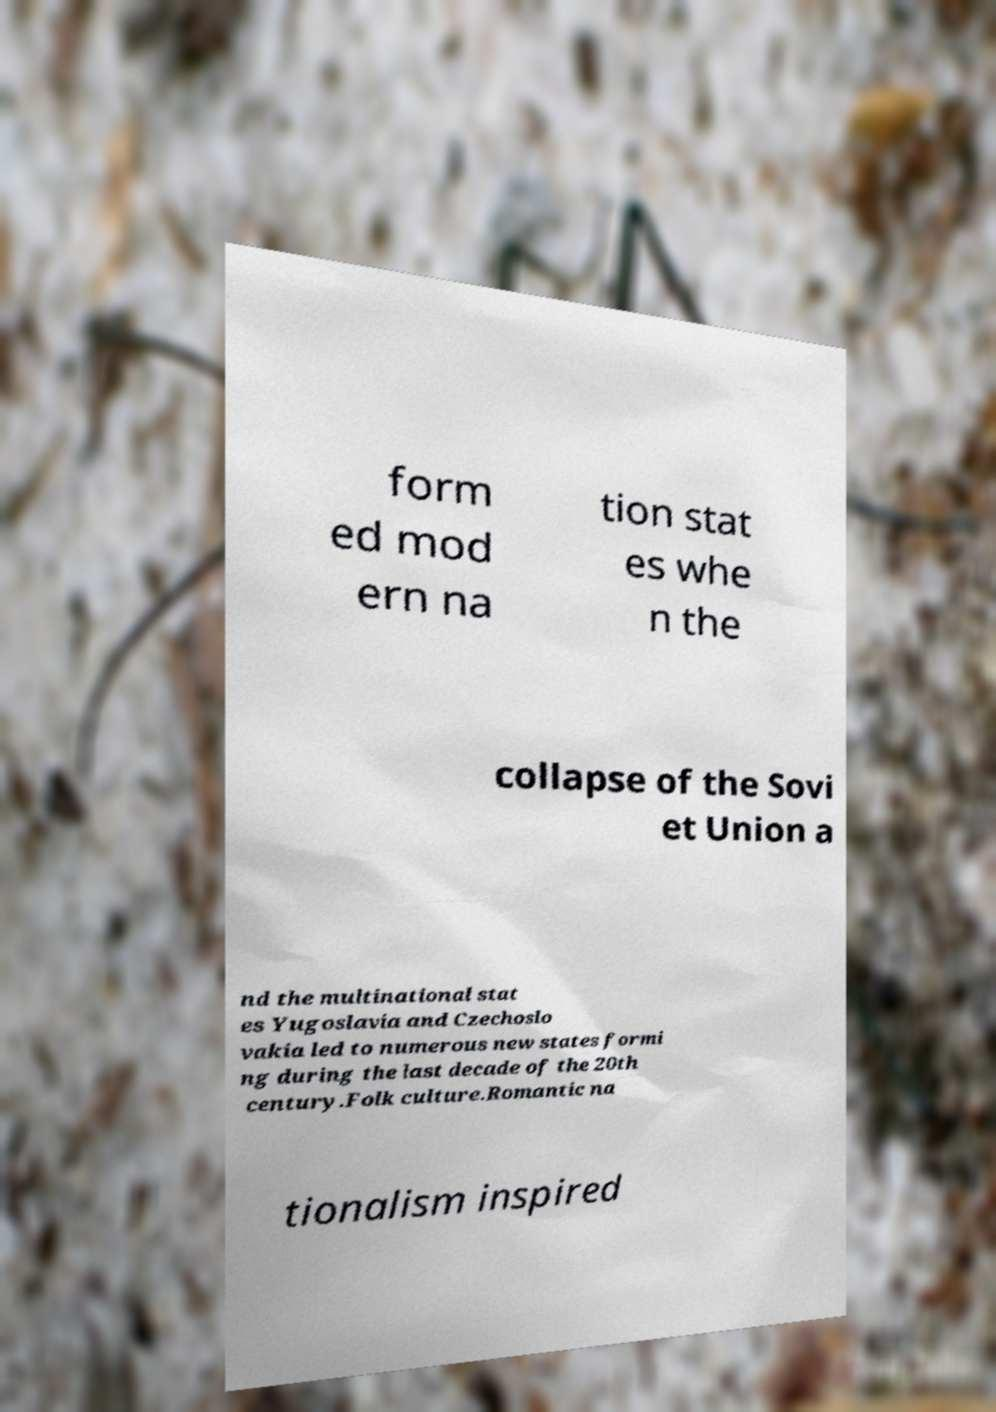Can you accurately transcribe the text from the provided image for me? form ed mod ern na tion stat es whe n the collapse of the Sovi et Union a nd the multinational stat es Yugoslavia and Czechoslo vakia led to numerous new states formi ng during the last decade of the 20th century.Folk culture.Romantic na tionalism inspired 